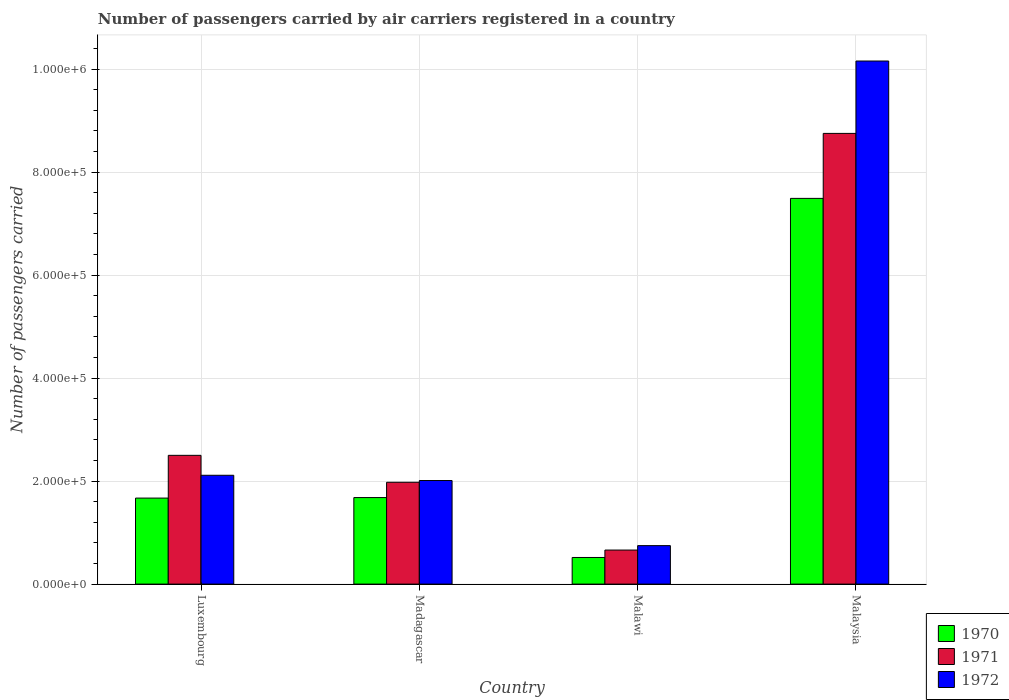How many different coloured bars are there?
Provide a succinct answer. 3. Are the number of bars per tick equal to the number of legend labels?
Offer a very short reply. Yes. Are the number of bars on each tick of the X-axis equal?
Offer a very short reply. Yes. What is the label of the 2nd group of bars from the left?
Offer a terse response. Madagascar. In how many cases, is the number of bars for a given country not equal to the number of legend labels?
Keep it short and to the point. 0. What is the number of passengers carried by air carriers in 1971 in Madagascar?
Give a very brief answer. 1.98e+05. Across all countries, what is the maximum number of passengers carried by air carriers in 1970?
Make the answer very short. 7.49e+05. Across all countries, what is the minimum number of passengers carried by air carriers in 1971?
Keep it short and to the point. 6.61e+04. In which country was the number of passengers carried by air carriers in 1972 maximum?
Keep it short and to the point. Malaysia. In which country was the number of passengers carried by air carriers in 1971 minimum?
Make the answer very short. Malawi. What is the total number of passengers carried by air carriers in 1972 in the graph?
Give a very brief answer. 1.50e+06. What is the difference between the number of passengers carried by air carriers in 1972 in Luxembourg and that in Malaysia?
Give a very brief answer. -8.04e+05. What is the difference between the number of passengers carried by air carriers in 1970 in Malaysia and the number of passengers carried by air carriers in 1972 in Luxembourg?
Provide a succinct answer. 5.38e+05. What is the average number of passengers carried by air carriers in 1972 per country?
Offer a very short reply. 3.76e+05. What is the difference between the number of passengers carried by air carriers of/in 1970 and number of passengers carried by air carriers of/in 1972 in Malaysia?
Your response must be concise. -2.67e+05. What is the ratio of the number of passengers carried by air carriers in 1971 in Luxembourg to that in Malawi?
Keep it short and to the point. 3.78. What is the difference between the highest and the second highest number of passengers carried by air carriers in 1972?
Your response must be concise. 8.14e+05. What is the difference between the highest and the lowest number of passengers carried by air carriers in 1971?
Make the answer very short. 8.09e+05. Is the sum of the number of passengers carried by air carriers in 1970 in Malawi and Malaysia greater than the maximum number of passengers carried by air carriers in 1971 across all countries?
Offer a terse response. No. How many bars are there?
Your answer should be very brief. 12. Are all the bars in the graph horizontal?
Ensure brevity in your answer.  No. How many countries are there in the graph?
Give a very brief answer. 4. Are the values on the major ticks of Y-axis written in scientific E-notation?
Offer a very short reply. Yes. Does the graph contain any zero values?
Offer a very short reply. No. Does the graph contain grids?
Make the answer very short. Yes. Where does the legend appear in the graph?
Ensure brevity in your answer.  Bottom right. How many legend labels are there?
Offer a very short reply. 3. How are the legend labels stacked?
Make the answer very short. Vertical. What is the title of the graph?
Offer a very short reply. Number of passengers carried by air carriers registered in a country. What is the label or title of the X-axis?
Make the answer very short. Country. What is the label or title of the Y-axis?
Provide a short and direct response. Number of passengers carried. What is the Number of passengers carried in 1970 in Luxembourg?
Give a very brief answer. 1.67e+05. What is the Number of passengers carried of 1971 in Luxembourg?
Offer a very short reply. 2.50e+05. What is the Number of passengers carried in 1972 in Luxembourg?
Your answer should be very brief. 2.11e+05. What is the Number of passengers carried in 1970 in Madagascar?
Provide a succinct answer. 1.68e+05. What is the Number of passengers carried in 1971 in Madagascar?
Make the answer very short. 1.98e+05. What is the Number of passengers carried in 1972 in Madagascar?
Keep it short and to the point. 2.01e+05. What is the Number of passengers carried in 1970 in Malawi?
Your response must be concise. 5.17e+04. What is the Number of passengers carried in 1971 in Malawi?
Offer a terse response. 6.61e+04. What is the Number of passengers carried of 1972 in Malawi?
Ensure brevity in your answer.  7.47e+04. What is the Number of passengers carried in 1970 in Malaysia?
Your answer should be compact. 7.49e+05. What is the Number of passengers carried of 1971 in Malaysia?
Ensure brevity in your answer.  8.75e+05. What is the Number of passengers carried of 1972 in Malaysia?
Keep it short and to the point. 1.02e+06. Across all countries, what is the maximum Number of passengers carried of 1970?
Your answer should be very brief. 7.49e+05. Across all countries, what is the maximum Number of passengers carried of 1971?
Provide a short and direct response. 8.75e+05. Across all countries, what is the maximum Number of passengers carried in 1972?
Provide a succinct answer. 1.02e+06. Across all countries, what is the minimum Number of passengers carried in 1970?
Your answer should be compact. 5.17e+04. Across all countries, what is the minimum Number of passengers carried in 1971?
Your answer should be compact. 6.61e+04. Across all countries, what is the minimum Number of passengers carried in 1972?
Your answer should be compact. 7.47e+04. What is the total Number of passengers carried in 1970 in the graph?
Your answer should be compact. 1.14e+06. What is the total Number of passengers carried in 1971 in the graph?
Offer a very short reply. 1.39e+06. What is the total Number of passengers carried of 1972 in the graph?
Your answer should be very brief. 1.50e+06. What is the difference between the Number of passengers carried of 1970 in Luxembourg and that in Madagascar?
Your response must be concise. -1000. What is the difference between the Number of passengers carried in 1971 in Luxembourg and that in Madagascar?
Provide a succinct answer. 5.23e+04. What is the difference between the Number of passengers carried in 1972 in Luxembourg and that in Madagascar?
Ensure brevity in your answer.  1.02e+04. What is the difference between the Number of passengers carried in 1970 in Luxembourg and that in Malawi?
Make the answer very short. 1.15e+05. What is the difference between the Number of passengers carried in 1971 in Luxembourg and that in Malawi?
Give a very brief answer. 1.84e+05. What is the difference between the Number of passengers carried of 1972 in Luxembourg and that in Malawi?
Ensure brevity in your answer.  1.37e+05. What is the difference between the Number of passengers carried in 1970 in Luxembourg and that in Malaysia?
Provide a short and direct response. -5.82e+05. What is the difference between the Number of passengers carried of 1971 in Luxembourg and that in Malaysia?
Offer a very short reply. -6.25e+05. What is the difference between the Number of passengers carried of 1972 in Luxembourg and that in Malaysia?
Keep it short and to the point. -8.04e+05. What is the difference between the Number of passengers carried of 1970 in Madagascar and that in Malawi?
Keep it short and to the point. 1.16e+05. What is the difference between the Number of passengers carried of 1971 in Madagascar and that in Malawi?
Give a very brief answer. 1.32e+05. What is the difference between the Number of passengers carried in 1972 in Madagascar and that in Malawi?
Ensure brevity in your answer.  1.26e+05. What is the difference between the Number of passengers carried in 1970 in Madagascar and that in Malaysia?
Offer a very short reply. -5.81e+05. What is the difference between the Number of passengers carried in 1971 in Madagascar and that in Malaysia?
Your response must be concise. -6.77e+05. What is the difference between the Number of passengers carried in 1972 in Madagascar and that in Malaysia?
Provide a succinct answer. -8.14e+05. What is the difference between the Number of passengers carried in 1970 in Malawi and that in Malaysia?
Your answer should be compact. -6.97e+05. What is the difference between the Number of passengers carried in 1971 in Malawi and that in Malaysia?
Ensure brevity in your answer.  -8.09e+05. What is the difference between the Number of passengers carried of 1972 in Malawi and that in Malaysia?
Offer a terse response. -9.41e+05. What is the difference between the Number of passengers carried of 1970 in Luxembourg and the Number of passengers carried of 1971 in Madagascar?
Provide a succinct answer. -3.07e+04. What is the difference between the Number of passengers carried in 1970 in Luxembourg and the Number of passengers carried in 1972 in Madagascar?
Ensure brevity in your answer.  -3.41e+04. What is the difference between the Number of passengers carried in 1971 in Luxembourg and the Number of passengers carried in 1972 in Madagascar?
Ensure brevity in your answer.  4.89e+04. What is the difference between the Number of passengers carried in 1970 in Luxembourg and the Number of passengers carried in 1971 in Malawi?
Give a very brief answer. 1.01e+05. What is the difference between the Number of passengers carried in 1970 in Luxembourg and the Number of passengers carried in 1972 in Malawi?
Ensure brevity in your answer.  9.23e+04. What is the difference between the Number of passengers carried of 1971 in Luxembourg and the Number of passengers carried of 1972 in Malawi?
Your response must be concise. 1.75e+05. What is the difference between the Number of passengers carried in 1970 in Luxembourg and the Number of passengers carried in 1971 in Malaysia?
Keep it short and to the point. -7.08e+05. What is the difference between the Number of passengers carried in 1970 in Luxembourg and the Number of passengers carried in 1972 in Malaysia?
Provide a succinct answer. -8.49e+05. What is the difference between the Number of passengers carried in 1971 in Luxembourg and the Number of passengers carried in 1972 in Malaysia?
Offer a very short reply. -7.66e+05. What is the difference between the Number of passengers carried of 1970 in Madagascar and the Number of passengers carried of 1971 in Malawi?
Your answer should be compact. 1.02e+05. What is the difference between the Number of passengers carried of 1970 in Madagascar and the Number of passengers carried of 1972 in Malawi?
Your answer should be compact. 9.33e+04. What is the difference between the Number of passengers carried in 1971 in Madagascar and the Number of passengers carried in 1972 in Malawi?
Your answer should be compact. 1.23e+05. What is the difference between the Number of passengers carried in 1970 in Madagascar and the Number of passengers carried in 1971 in Malaysia?
Provide a short and direct response. -7.07e+05. What is the difference between the Number of passengers carried of 1970 in Madagascar and the Number of passengers carried of 1972 in Malaysia?
Offer a very short reply. -8.48e+05. What is the difference between the Number of passengers carried in 1971 in Madagascar and the Number of passengers carried in 1972 in Malaysia?
Your answer should be very brief. -8.18e+05. What is the difference between the Number of passengers carried in 1970 in Malawi and the Number of passengers carried in 1971 in Malaysia?
Your answer should be compact. -8.23e+05. What is the difference between the Number of passengers carried of 1970 in Malawi and the Number of passengers carried of 1972 in Malaysia?
Offer a terse response. -9.64e+05. What is the difference between the Number of passengers carried in 1971 in Malawi and the Number of passengers carried in 1972 in Malaysia?
Your response must be concise. -9.50e+05. What is the average Number of passengers carried in 1970 per country?
Your answer should be very brief. 2.84e+05. What is the average Number of passengers carried of 1971 per country?
Offer a terse response. 3.47e+05. What is the average Number of passengers carried in 1972 per country?
Keep it short and to the point. 3.76e+05. What is the difference between the Number of passengers carried in 1970 and Number of passengers carried in 1971 in Luxembourg?
Give a very brief answer. -8.30e+04. What is the difference between the Number of passengers carried of 1970 and Number of passengers carried of 1972 in Luxembourg?
Ensure brevity in your answer.  -4.43e+04. What is the difference between the Number of passengers carried of 1971 and Number of passengers carried of 1972 in Luxembourg?
Keep it short and to the point. 3.87e+04. What is the difference between the Number of passengers carried of 1970 and Number of passengers carried of 1971 in Madagascar?
Give a very brief answer. -2.97e+04. What is the difference between the Number of passengers carried of 1970 and Number of passengers carried of 1972 in Madagascar?
Your answer should be compact. -3.31e+04. What is the difference between the Number of passengers carried of 1971 and Number of passengers carried of 1972 in Madagascar?
Give a very brief answer. -3400. What is the difference between the Number of passengers carried of 1970 and Number of passengers carried of 1971 in Malawi?
Offer a terse response. -1.44e+04. What is the difference between the Number of passengers carried of 1970 and Number of passengers carried of 1972 in Malawi?
Provide a succinct answer. -2.30e+04. What is the difference between the Number of passengers carried in 1971 and Number of passengers carried in 1972 in Malawi?
Keep it short and to the point. -8600. What is the difference between the Number of passengers carried of 1970 and Number of passengers carried of 1971 in Malaysia?
Keep it short and to the point. -1.26e+05. What is the difference between the Number of passengers carried of 1970 and Number of passengers carried of 1972 in Malaysia?
Give a very brief answer. -2.67e+05. What is the difference between the Number of passengers carried of 1971 and Number of passengers carried of 1972 in Malaysia?
Keep it short and to the point. -1.40e+05. What is the ratio of the Number of passengers carried in 1971 in Luxembourg to that in Madagascar?
Your answer should be compact. 1.26. What is the ratio of the Number of passengers carried in 1972 in Luxembourg to that in Madagascar?
Your answer should be compact. 1.05. What is the ratio of the Number of passengers carried of 1970 in Luxembourg to that in Malawi?
Keep it short and to the point. 3.23. What is the ratio of the Number of passengers carried of 1971 in Luxembourg to that in Malawi?
Your response must be concise. 3.78. What is the ratio of the Number of passengers carried of 1972 in Luxembourg to that in Malawi?
Your answer should be very brief. 2.83. What is the ratio of the Number of passengers carried in 1970 in Luxembourg to that in Malaysia?
Offer a terse response. 0.22. What is the ratio of the Number of passengers carried of 1971 in Luxembourg to that in Malaysia?
Provide a short and direct response. 0.29. What is the ratio of the Number of passengers carried in 1972 in Luxembourg to that in Malaysia?
Give a very brief answer. 0.21. What is the ratio of the Number of passengers carried of 1970 in Madagascar to that in Malawi?
Your answer should be very brief. 3.25. What is the ratio of the Number of passengers carried in 1971 in Madagascar to that in Malawi?
Ensure brevity in your answer.  2.99. What is the ratio of the Number of passengers carried in 1972 in Madagascar to that in Malawi?
Your answer should be compact. 2.69. What is the ratio of the Number of passengers carried of 1970 in Madagascar to that in Malaysia?
Your response must be concise. 0.22. What is the ratio of the Number of passengers carried of 1971 in Madagascar to that in Malaysia?
Offer a terse response. 0.23. What is the ratio of the Number of passengers carried of 1972 in Madagascar to that in Malaysia?
Ensure brevity in your answer.  0.2. What is the ratio of the Number of passengers carried of 1970 in Malawi to that in Malaysia?
Offer a very short reply. 0.07. What is the ratio of the Number of passengers carried in 1971 in Malawi to that in Malaysia?
Your response must be concise. 0.08. What is the ratio of the Number of passengers carried in 1972 in Malawi to that in Malaysia?
Make the answer very short. 0.07. What is the difference between the highest and the second highest Number of passengers carried in 1970?
Keep it short and to the point. 5.81e+05. What is the difference between the highest and the second highest Number of passengers carried of 1971?
Provide a succinct answer. 6.25e+05. What is the difference between the highest and the second highest Number of passengers carried in 1972?
Your response must be concise. 8.04e+05. What is the difference between the highest and the lowest Number of passengers carried of 1970?
Your response must be concise. 6.97e+05. What is the difference between the highest and the lowest Number of passengers carried in 1971?
Your response must be concise. 8.09e+05. What is the difference between the highest and the lowest Number of passengers carried in 1972?
Give a very brief answer. 9.41e+05. 